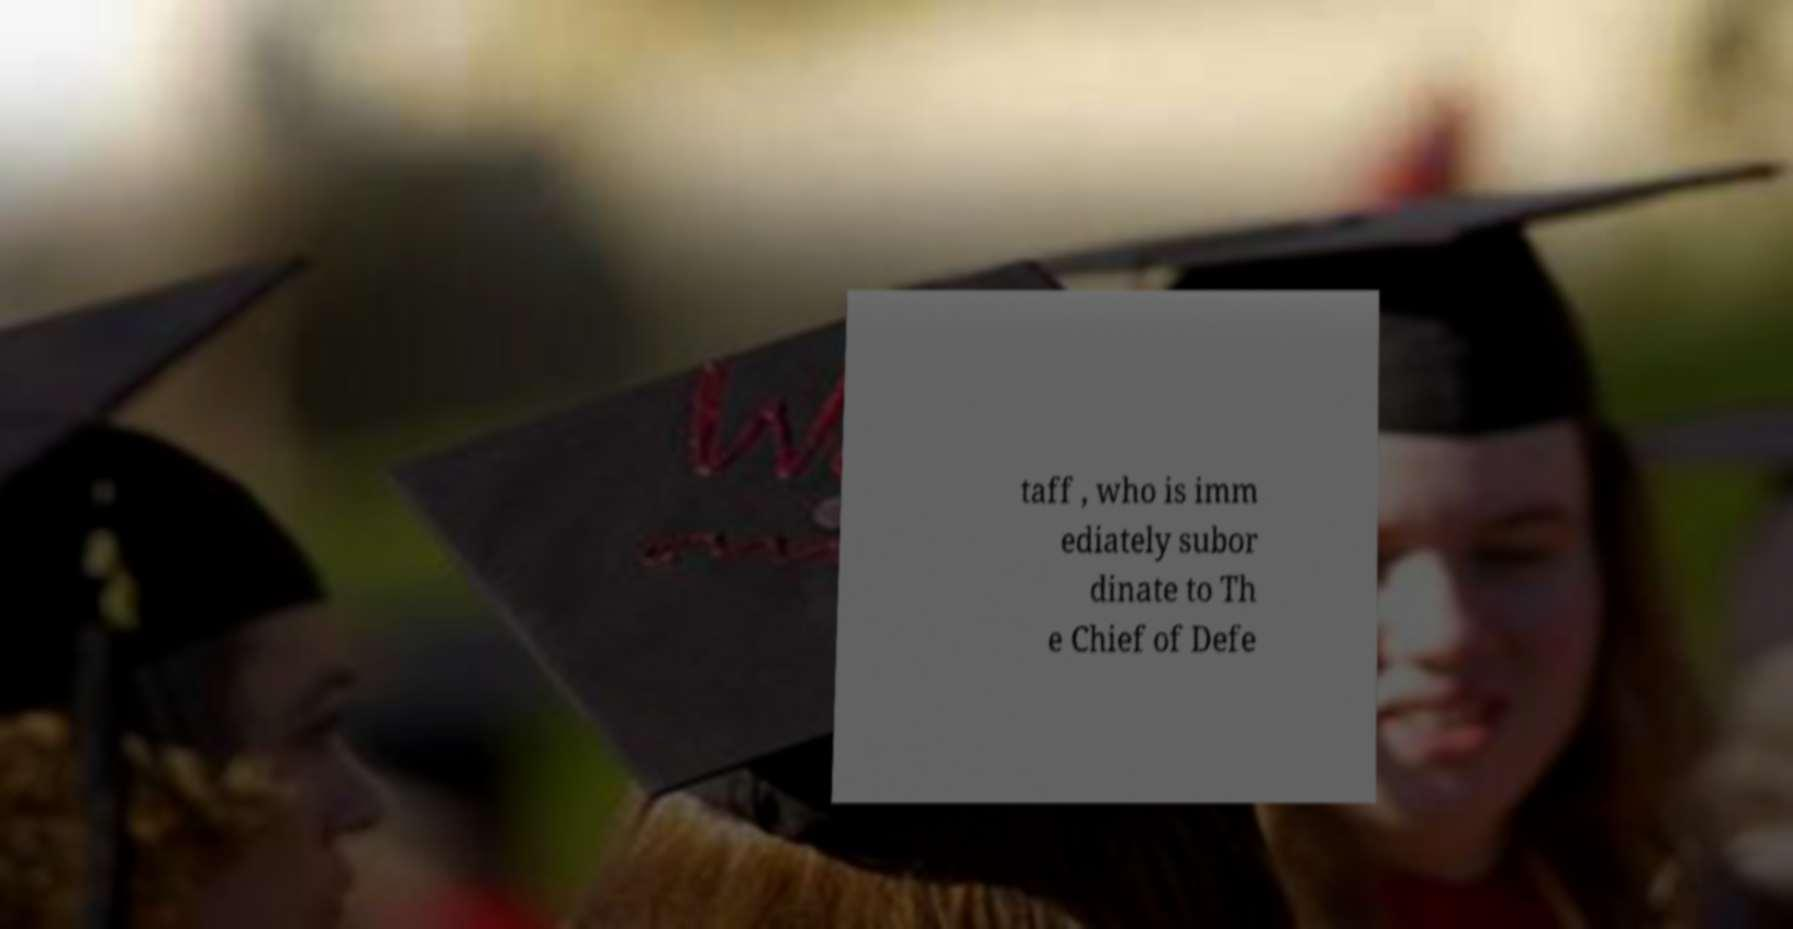Could you assist in decoding the text presented in this image and type it out clearly? taff , who is imm ediately subor dinate to Th e Chief of Defe 